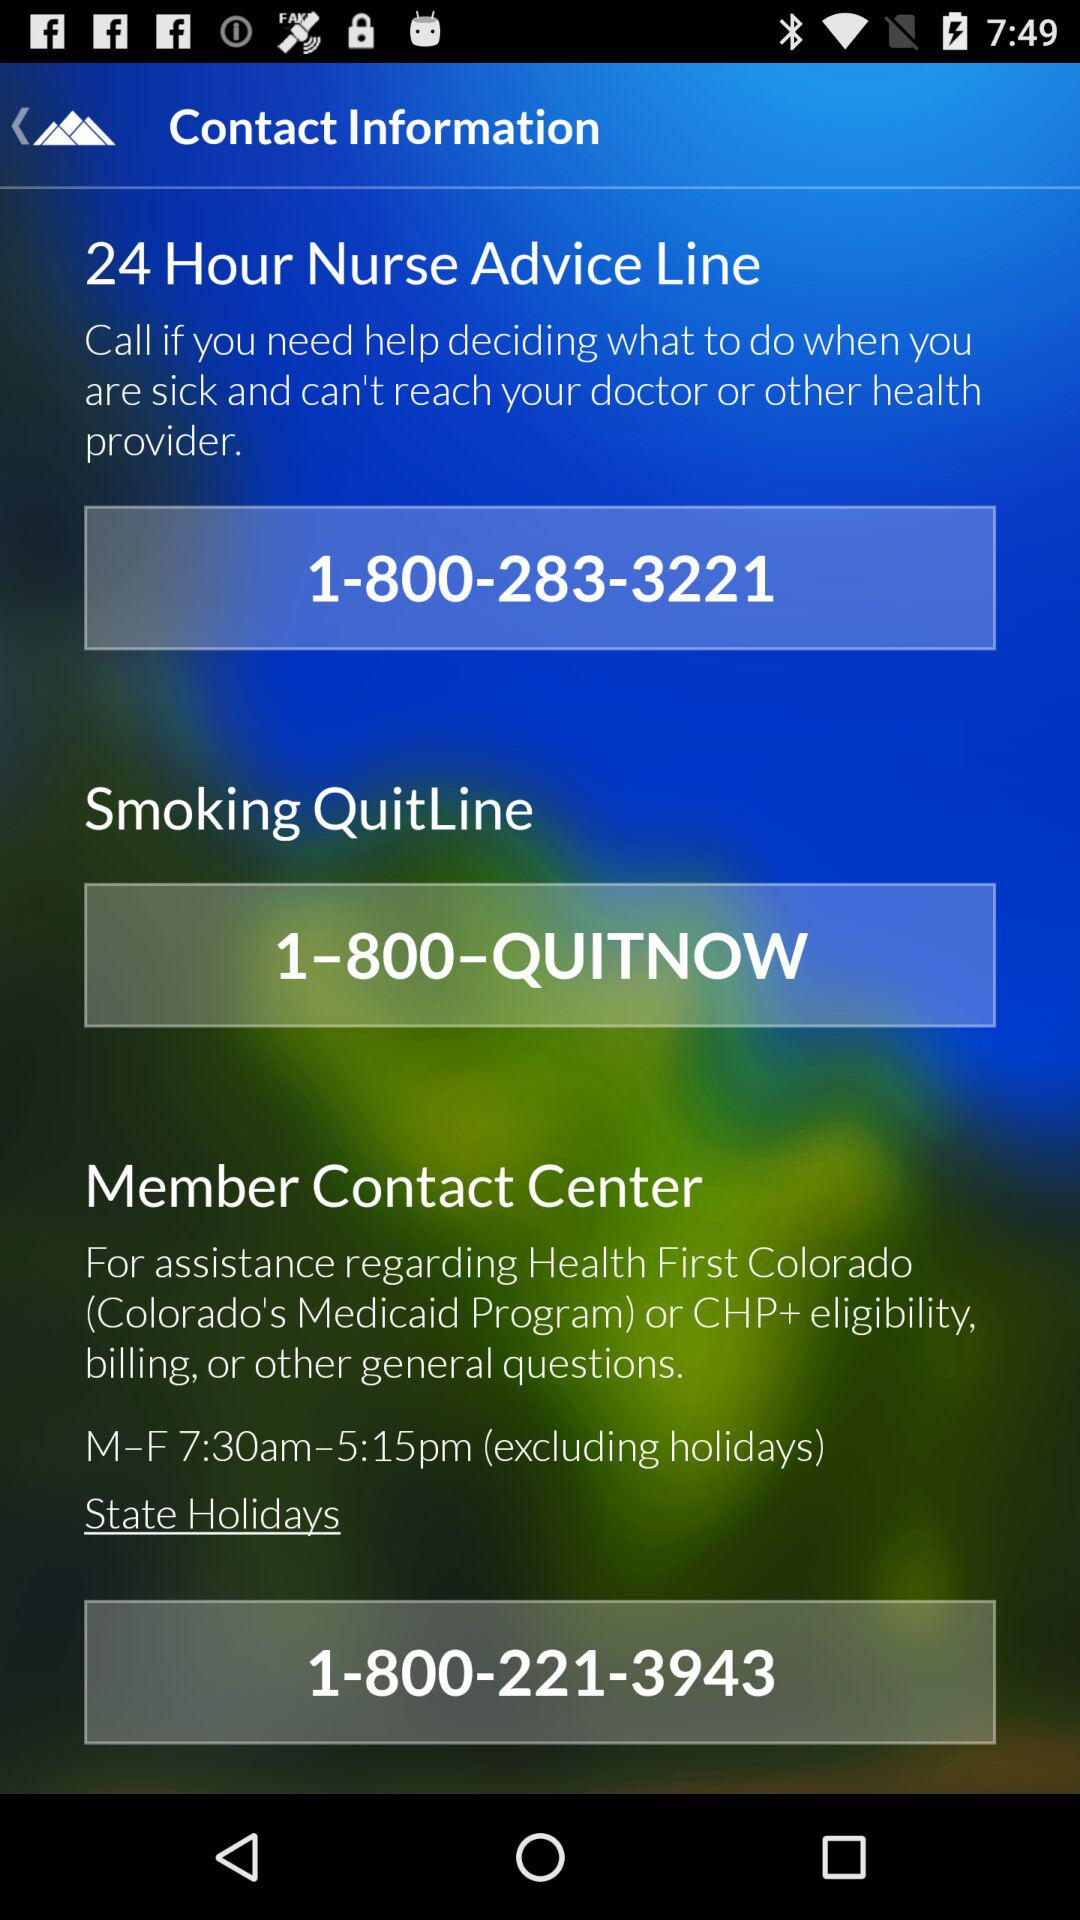What is the contact number for the "24-Hour Nurse Advice Line"? The contact number for the "24-Hour Nurse Advice Line" is 1-800-283-3221. 